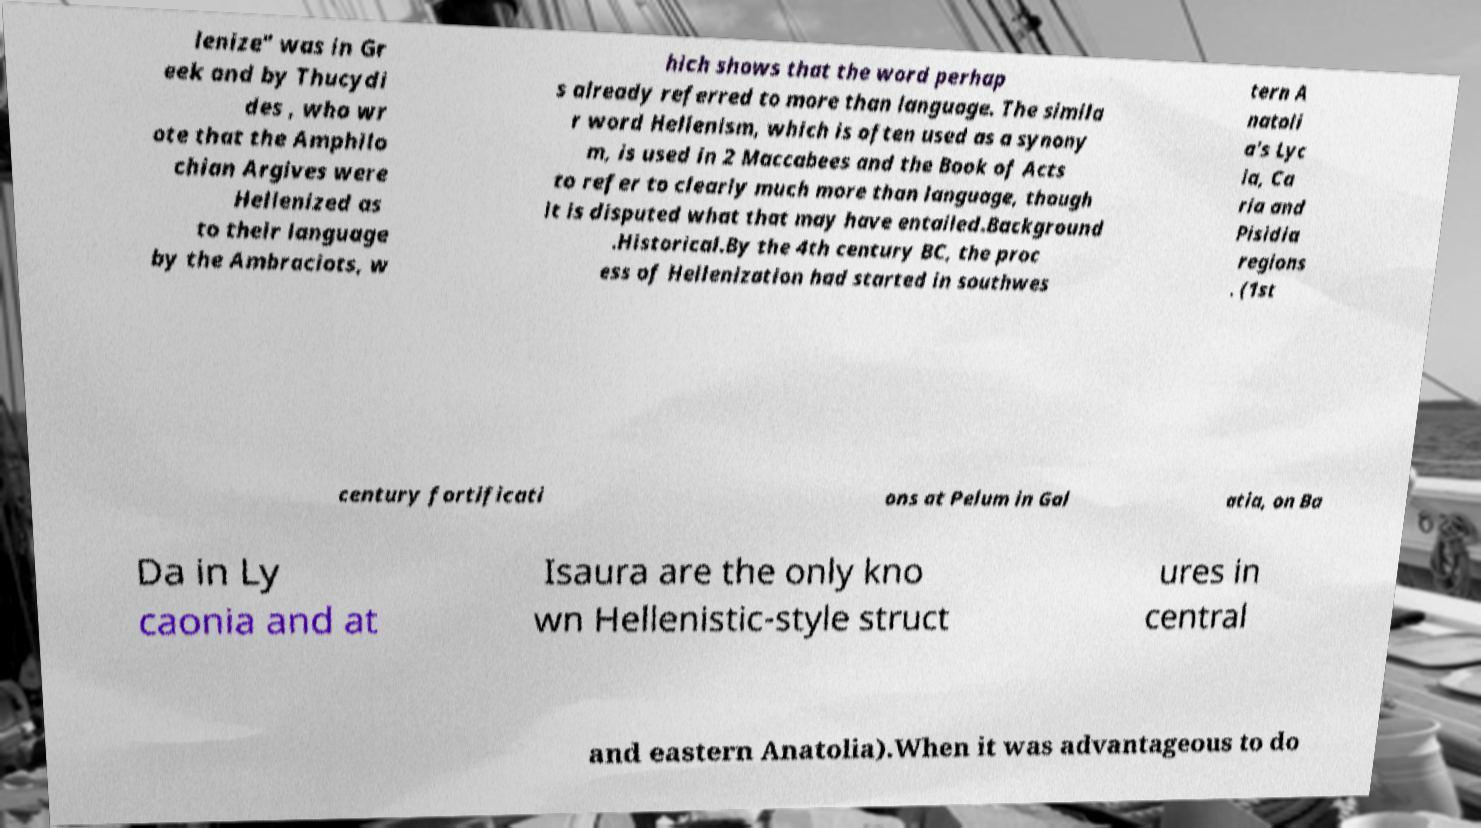Could you assist in decoding the text presented in this image and type it out clearly? lenize" was in Gr eek and by Thucydi des , who wr ote that the Amphilo chian Argives were Hellenized as to their language by the Ambraciots, w hich shows that the word perhap s already referred to more than language. The simila r word Hellenism, which is often used as a synony m, is used in 2 Maccabees and the Book of Acts to refer to clearly much more than language, though it is disputed what that may have entailed.Background .Historical.By the 4th century BC, the proc ess of Hellenization had started in southwes tern A natoli a's Lyc ia, Ca ria and Pisidia regions . (1st century fortificati ons at Pelum in Gal atia, on Ba Da in Ly caonia and at Isaura are the only kno wn Hellenistic-style struct ures in central and eastern Anatolia).When it was advantageous to do 